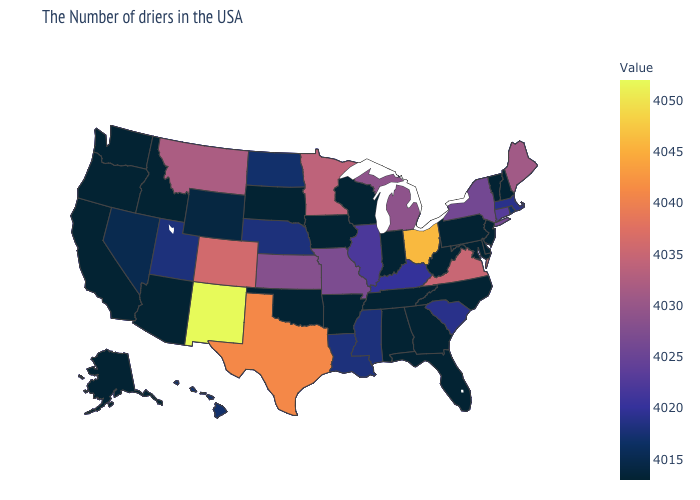Which states have the lowest value in the USA?
Quick response, please. New Hampshire, Vermont, New Jersey, Delaware, Maryland, Pennsylvania, North Carolina, West Virginia, Florida, Georgia, Indiana, Alabama, Tennessee, Wisconsin, Arkansas, Iowa, Oklahoma, South Dakota, Arizona, Idaho, California, Washington, Oregon, Alaska. Which states hav the highest value in the South?
Answer briefly. Texas. Which states have the lowest value in the USA?
Quick response, please. New Hampshire, Vermont, New Jersey, Delaware, Maryland, Pennsylvania, North Carolina, West Virginia, Florida, Georgia, Indiana, Alabama, Tennessee, Wisconsin, Arkansas, Iowa, Oklahoma, South Dakota, Arizona, Idaho, California, Washington, Oregon, Alaska. Does New Mexico have the highest value in the West?
Write a very short answer. Yes. Which states have the lowest value in the South?
Be succinct. Delaware, Maryland, North Carolina, West Virginia, Florida, Georgia, Alabama, Tennessee, Arkansas, Oklahoma. Among the states that border Colorado , which have the highest value?
Write a very short answer. New Mexico. 